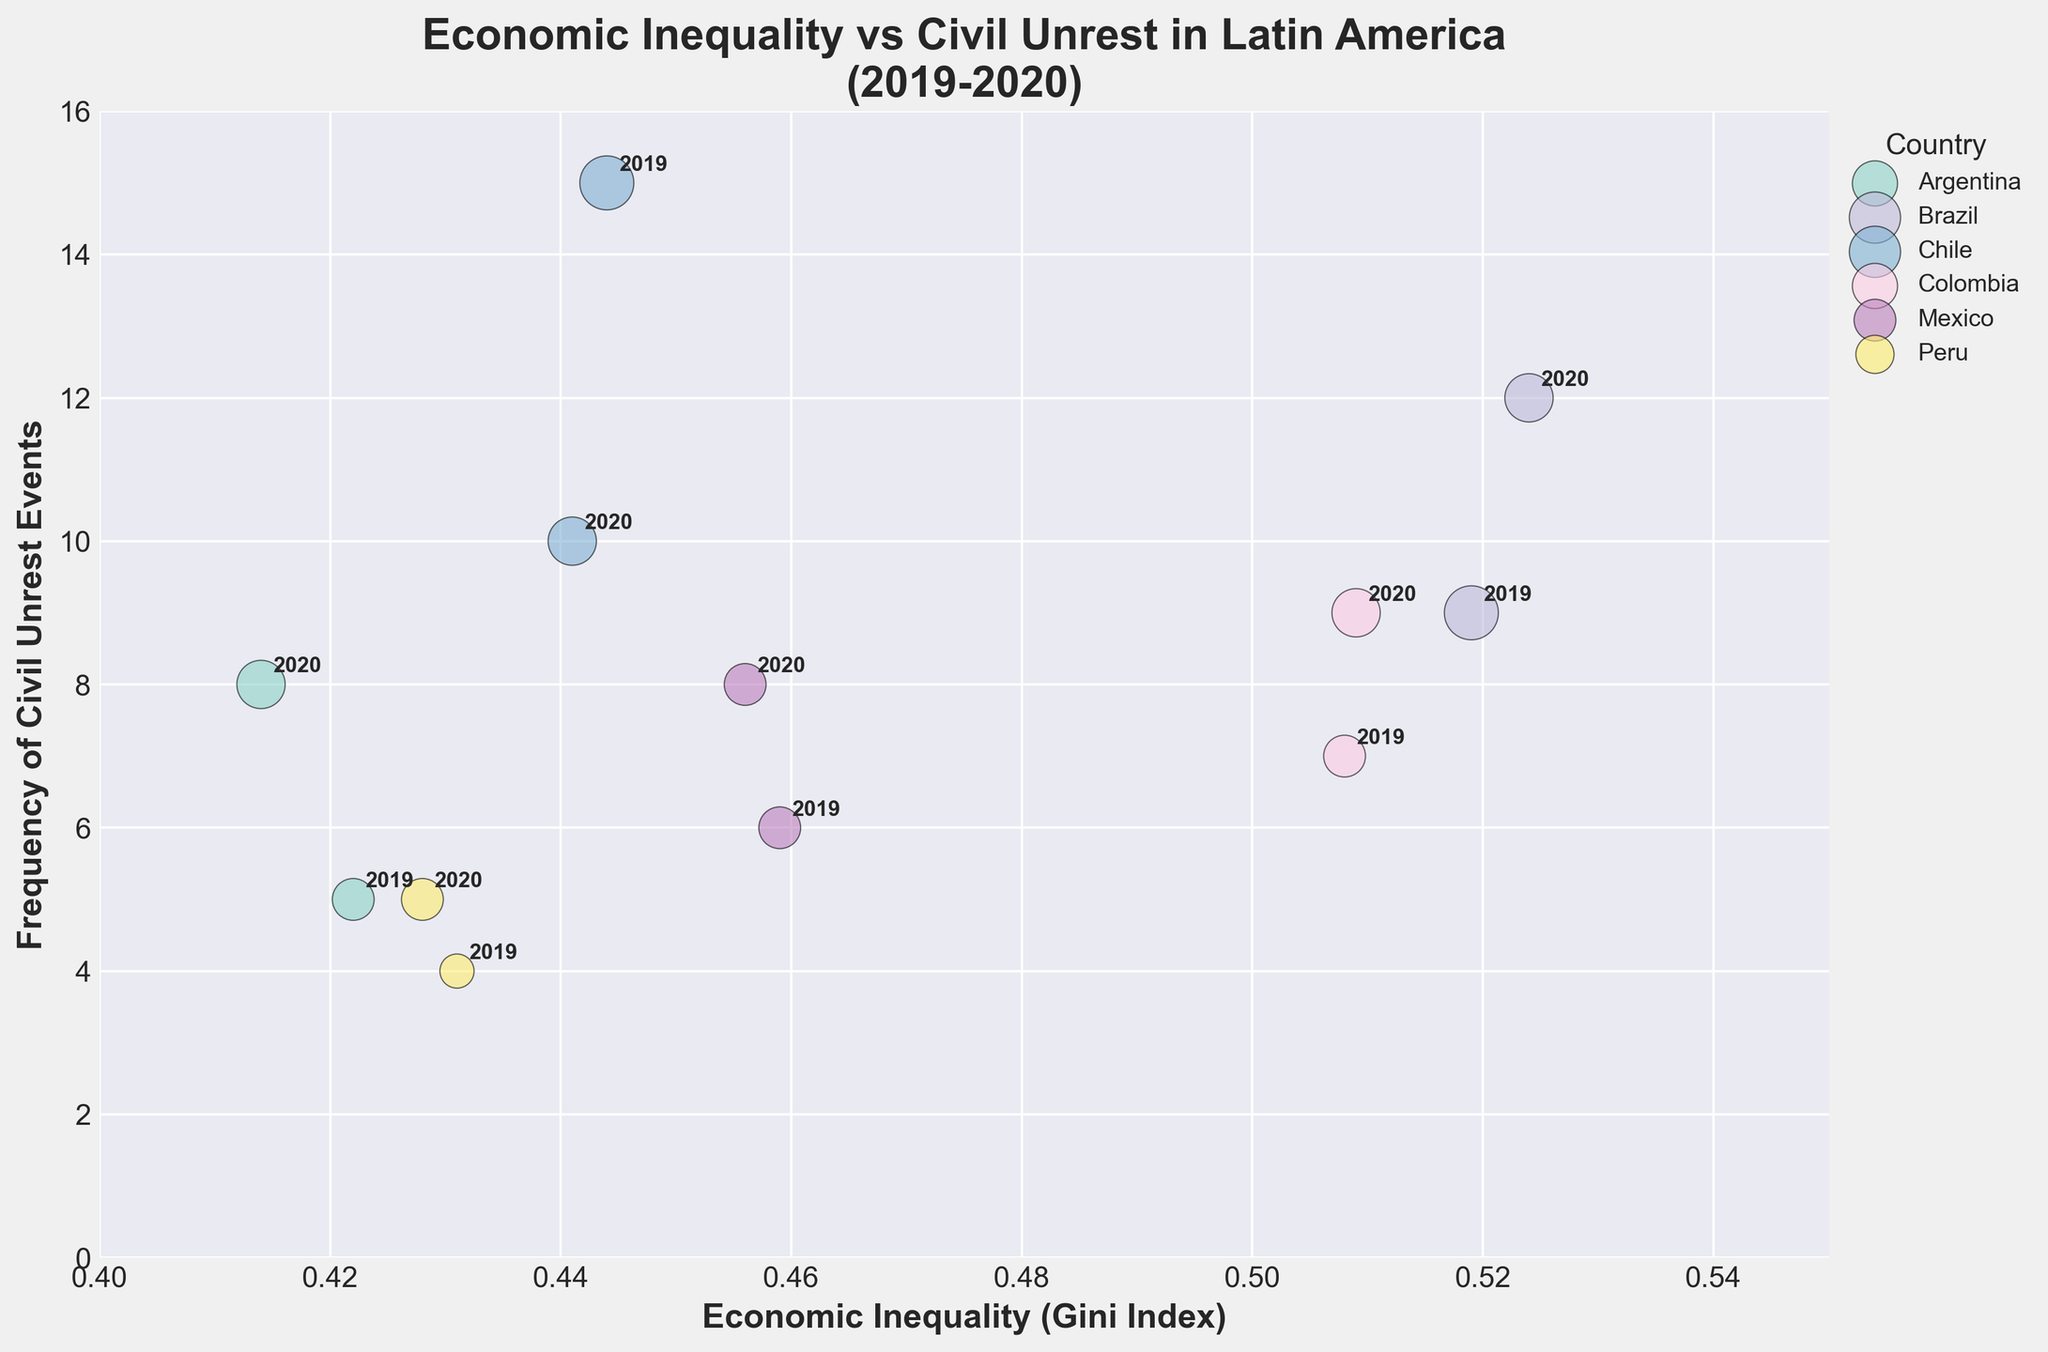What's the title of the figure? The title of the figure is displayed at the top and reads: 'Economic Inequality vs Civil Unrest in Latin America\n(2019-2020)'.
Answer: Economic Inequality vs Civil Unrest in Latin America (2019-2020) What does the x-axis represent? The label of the x-axis indicates it's representing 'Economic Inequality (Gini Index)'.
Answer: Economic Inequality (Gini Index) How many countries are represented in the figure? The number of distinct colors and labels in the legend corresponds to the number of countries represented in the figure. There are six unique labels.
Answer: 6 Which country had the highest frequency of civil unrest events in 2019? By looking at the y-axis values and finding the highest point for the year 2019 annotations, we see that Chile's bubble is at the highest y-value.
Answer: Chile What is the frequency of civil unrest events in Mexico in 2020? Locate Mexico in the legend, find the bubble with the annotation '2020', and read its y-axis value. The y-value for Mexico's 2020 bubble is 8.
Answer: 8 Which country saw an increase in economic inequality from 2019 to 2020? Compare the x-axis values for each country's bubbles from 2019 to 2020. Brazil shows an increase from approximately 0.519 to 0.524.
Answer: Brazil Which year had more frequent civil unrest events in Argentina? Compare the y-axis values of Argentina's bubbles between 2019 and 2020. The 2020 bubble is positioned higher on the y-axis at 8 compared to 5 in 2019.
Answer: 2020 How does the severity of civil unrest in Chile compare between 2019 and 2020? Locate Chile in the legend, compare the bubble sizes for 2019 and 2020. The bubble for 2019 (size 5 * 100) is larger than the bubble for 2020 (size 4 * 100).
Answer: Higher in 2019 Which country had the lowest economic inequality in 2020? Locate the bubbles annotated as 2020 and find the one with the lowest x-axis value. Peru has the lowest Gini index at approximately 0.428.
Answer: Peru What is the overall trend between economic inequality and frequency of civil unrest events? Higher economic inequality generally corresponds to higher frequency of civil unrest events, as indicated by the general upward trend in the bubble positions from left to right on the x-axis.
Answer: Positive correlation 